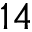Convert formula to latex. <formula><loc_0><loc_0><loc_500><loc_500>1 4</formula> 